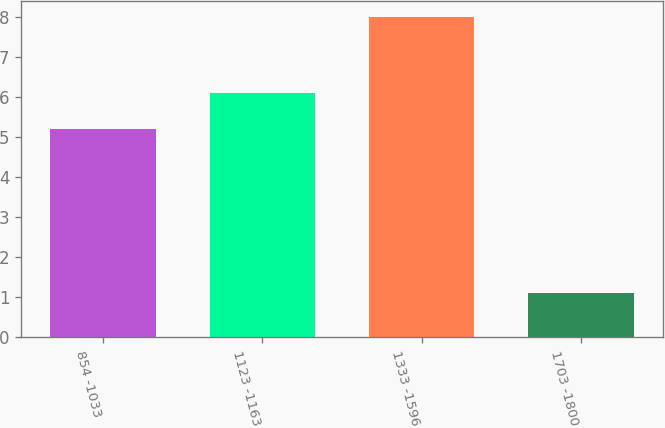Convert chart to OTSL. <chart><loc_0><loc_0><loc_500><loc_500><bar_chart><fcel>854 -1033<fcel>1123 -1163<fcel>1333 -1596<fcel>1703 -1800<nl><fcel>5.2<fcel>6.1<fcel>8<fcel>1.1<nl></chart> 